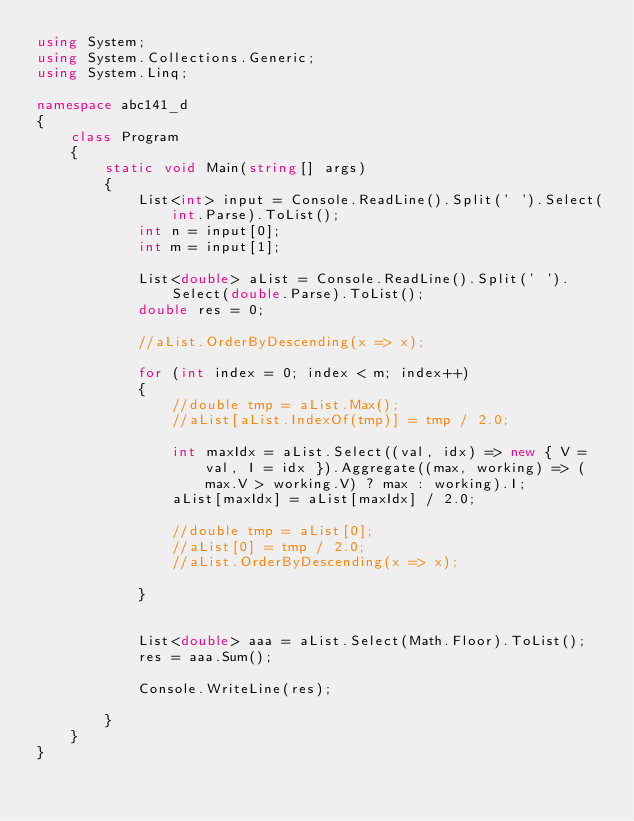Convert code to text. <code><loc_0><loc_0><loc_500><loc_500><_C#_>using System;
using System.Collections.Generic;
using System.Linq;

namespace abc141_d
{
    class Program
    {
        static void Main(string[] args)
        {
            List<int> input = Console.ReadLine().Split(' ').Select(int.Parse).ToList();
            int n = input[0];
            int m = input[1];

            List<double> aList = Console.ReadLine().Split(' ').Select(double.Parse).ToList();
            double res = 0;

            //aList.OrderByDescending(x => x);

            for (int index = 0; index < m; index++)
            {
                //double tmp = aList.Max();
                //aList[aList.IndexOf(tmp)] = tmp / 2.0;

                int maxIdx = aList.Select((val, idx) => new { V = val, I = idx }).Aggregate((max, working) => (max.V > working.V) ? max : working).I;
                aList[maxIdx] = aList[maxIdx] / 2.0;

                //double tmp = aList[0];
                //aList[0] = tmp / 2.0;
                //aList.OrderByDescending(x => x);

            }


            List<double> aaa = aList.Select(Math.Floor).ToList();
            res = aaa.Sum();

            Console.WriteLine(res);

        }
    }
}
</code> 